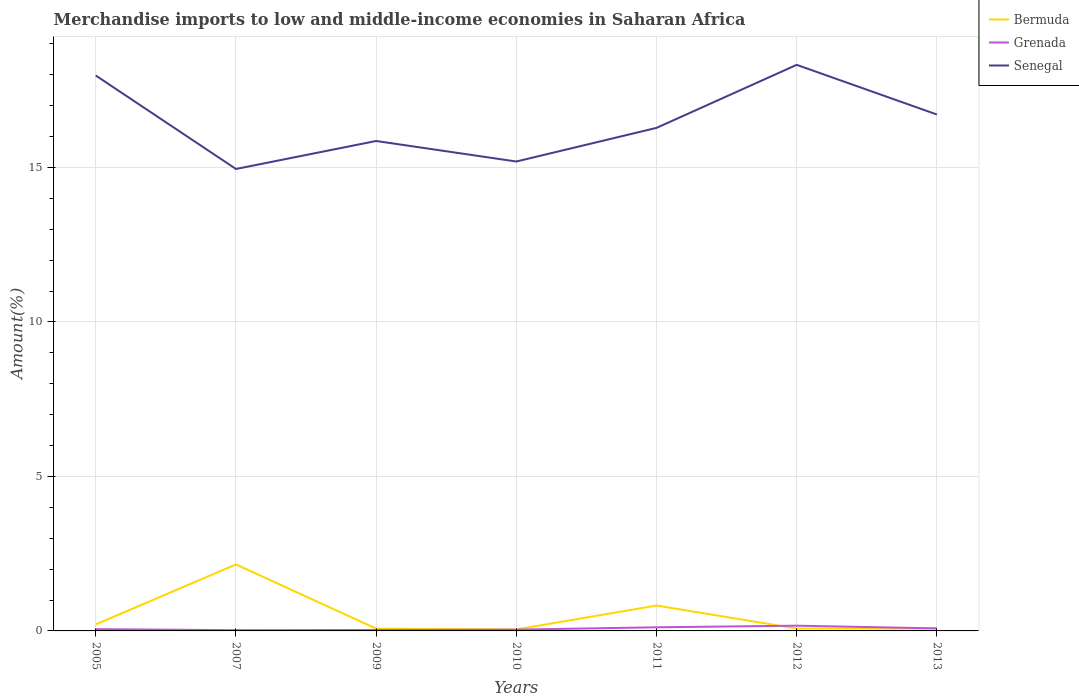Does the line corresponding to Senegal intersect with the line corresponding to Grenada?
Your answer should be very brief. No. Is the number of lines equal to the number of legend labels?
Keep it short and to the point. Yes. Across all years, what is the maximum percentage of amount earned from merchandise imports in Senegal?
Your answer should be very brief. 14.95. In which year was the percentage of amount earned from merchandise imports in Senegal maximum?
Give a very brief answer. 2007. What is the total percentage of amount earned from merchandise imports in Bermuda in the graph?
Your answer should be very brief. 0.75. What is the difference between the highest and the second highest percentage of amount earned from merchandise imports in Grenada?
Keep it short and to the point. 0.15. Is the percentage of amount earned from merchandise imports in Grenada strictly greater than the percentage of amount earned from merchandise imports in Bermuda over the years?
Give a very brief answer. No. What is the difference between two consecutive major ticks on the Y-axis?
Make the answer very short. 5. Are the values on the major ticks of Y-axis written in scientific E-notation?
Your response must be concise. No. Does the graph contain any zero values?
Provide a short and direct response. No. Does the graph contain grids?
Offer a terse response. Yes. How many legend labels are there?
Offer a very short reply. 3. How are the legend labels stacked?
Offer a very short reply. Vertical. What is the title of the graph?
Keep it short and to the point. Merchandise imports to low and middle-income economies in Saharan Africa. Does "Panama" appear as one of the legend labels in the graph?
Your answer should be compact. No. What is the label or title of the Y-axis?
Your answer should be compact. Amount(%). What is the Amount(%) of Bermuda in 2005?
Your answer should be compact. 0.21. What is the Amount(%) in Grenada in 2005?
Give a very brief answer. 0.06. What is the Amount(%) in Senegal in 2005?
Ensure brevity in your answer.  17.98. What is the Amount(%) of Bermuda in 2007?
Make the answer very short. 2.15. What is the Amount(%) of Grenada in 2007?
Provide a succinct answer. 0.02. What is the Amount(%) of Senegal in 2007?
Provide a succinct answer. 14.95. What is the Amount(%) of Bermuda in 2009?
Provide a succinct answer. 0.07. What is the Amount(%) in Grenada in 2009?
Offer a very short reply. 0.03. What is the Amount(%) of Senegal in 2009?
Provide a succinct answer. 15.86. What is the Amount(%) of Bermuda in 2010?
Your answer should be compact. 0.05. What is the Amount(%) of Grenada in 2010?
Make the answer very short. 0.04. What is the Amount(%) of Senegal in 2010?
Offer a very short reply. 15.19. What is the Amount(%) of Bermuda in 2011?
Keep it short and to the point. 0.82. What is the Amount(%) in Grenada in 2011?
Keep it short and to the point. 0.12. What is the Amount(%) of Senegal in 2011?
Keep it short and to the point. 16.28. What is the Amount(%) in Bermuda in 2012?
Provide a succinct answer. 0.08. What is the Amount(%) in Grenada in 2012?
Your answer should be compact. 0.17. What is the Amount(%) in Senegal in 2012?
Your answer should be very brief. 18.32. What is the Amount(%) of Bermuda in 2013?
Offer a terse response. 0.08. What is the Amount(%) in Grenada in 2013?
Make the answer very short. 0.08. What is the Amount(%) in Senegal in 2013?
Give a very brief answer. 16.72. Across all years, what is the maximum Amount(%) in Bermuda?
Your response must be concise. 2.15. Across all years, what is the maximum Amount(%) of Grenada?
Your answer should be compact. 0.17. Across all years, what is the maximum Amount(%) in Senegal?
Provide a succinct answer. 18.32. Across all years, what is the minimum Amount(%) in Bermuda?
Your response must be concise. 0.05. Across all years, what is the minimum Amount(%) of Grenada?
Your answer should be compact. 0.02. Across all years, what is the minimum Amount(%) in Senegal?
Offer a terse response. 14.95. What is the total Amount(%) of Bermuda in the graph?
Your answer should be very brief. 3.46. What is the total Amount(%) in Grenada in the graph?
Your answer should be compact. 0.52. What is the total Amount(%) in Senegal in the graph?
Make the answer very short. 115.31. What is the difference between the Amount(%) of Bermuda in 2005 and that in 2007?
Make the answer very short. -1.94. What is the difference between the Amount(%) in Grenada in 2005 and that in 2007?
Provide a succinct answer. 0.03. What is the difference between the Amount(%) of Senegal in 2005 and that in 2007?
Provide a short and direct response. 3.02. What is the difference between the Amount(%) of Bermuda in 2005 and that in 2009?
Offer a terse response. 0.14. What is the difference between the Amount(%) of Grenada in 2005 and that in 2009?
Provide a short and direct response. 0.03. What is the difference between the Amount(%) of Senegal in 2005 and that in 2009?
Offer a terse response. 2.12. What is the difference between the Amount(%) in Bermuda in 2005 and that in 2010?
Offer a terse response. 0.16. What is the difference between the Amount(%) of Grenada in 2005 and that in 2010?
Offer a terse response. 0.02. What is the difference between the Amount(%) of Senegal in 2005 and that in 2010?
Provide a succinct answer. 2.78. What is the difference between the Amount(%) in Bermuda in 2005 and that in 2011?
Your answer should be compact. -0.61. What is the difference between the Amount(%) of Grenada in 2005 and that in 2011?
Provide a short and direct response. -0.06. What is the difference between the Amount(%) of Senegal in 2005 and that in 2011?
Offer a very short reply. 1.69. What is the difference between the Amount(%) in Bermuda in 2005 and that in 2012?
Make the answer very short. 0.13. What is the difference between the Amount(%) in Grenada in 2005 and that in 2012?
Your answer should be very brief. -0.11. What is the difference between the Amount(%) in Senegal in 2005 and that in 2012?
Offer a terse response. -0.35. What is the difference between the Amount(%) of Bermuda in 2005 and that in 2013?
Make the answer very short. 0.13. What is the difference between the Amount(%) of Grenada in 2005 and that in 2013?
Provide a short and direct response. -0.02. What is the difference between the Amount(%) in Senegal in 2005 and that in 2013?
Ensure brevity in your answer.  1.26. What is the difference between the Amount(%) of Bermuda in 2007 and that in 2009?
Provide a succinct answer. 2.08. What is the difference between the Amount(%) in Grenada in 2007 and that in 2009?
Your answer should be very brief. -0.01. What is the difference between the Amount(%) in Senegal in 2007 and that in 2009?
Your answer should be compact. -0.91. What is the difference between the Amount(%) of Bermuda in 2007 and that in 2010?
Provide a succinct answer. 2.1. What is the difference between the Amount(%) of Grenada in 2007 and that in 2010?
Your answer should be very brief. -0.02. What is the difference between the Amount(%) in Senegal in 2007 and that in 2010?
Ensure brevity in your answer.  -0.24. What is the difference between the Amount(%) in Bermuda in 2007 and that in 2011?
Offer a terse response. 1.33. What is the difference between the Amount(%) of Grenada in 2007 and that in 2011?
Ensure brevity in your answer.  -0.09. What is the difference between the Amount(%) of Senegal in 2007 and that in 2011?
Offer a terse response. -1.33. What is the difference between the Amount(%) of Bermuda in 2007 and that in 2012?
Make the answer very short. 2.08. What is the difference between the Amount(%) of Grenada in 2007 and that in 2012?
Make the answer very short. -0.15. What is the difference between the Amount(%) in Senegal in 2007 and that in 2012?
Offer a very short reply. -3.37. What is the difference between the Amount(%) of Bermuda in 2007 and that in 2013?
Ensure brevity in your answer.  2.08. What is the difference between the Amount(%) of Grenada in 2007 and that in 2013?
Keep it short and to the point. -0.06. What is the difference between the Amount(%) of Senegal in 2007 and that in 2013?
Keep it short and to the point. -1.76. What is the difference between the Amount(%) in Bermuda in 2009 and that in 2010?
Keep it short and to the point. 0.03. What is the difference between the Amount(%) of Grenada in 2009 and that in 2010?
Make the answer very short. -0.01. What is the difference between the Amount(%) in Senegal in 2009 and that in 2010?
Offer a very short reply. 0.66. What is the difference between the Amount(%) of Bermuda in 2009 and that in 2011?
Your answer should be compact. -0.75. What is the difference between the Amount(%) in Grenada in 2009 and that in 2011?
Provide a short and direct response. -0.09. What is the difference between the Amount(%) of Senegal in 2009 and that in 2011?
Your answer should be compact. -0.42. What is the difference between the Amount(%) in Bermuda in 2009 and that in 2012?
Provide a succinct answer. -0. What is the difference between the Amount(%) of Grenada in 2009 and that in 2012?
Give a very brief answer. -0.14. What is the difference between the Amount(%) in Senegal in 2009 and that in 2012?
Provide a short and direct response. -2.46. What is the difference between the Amount(%) in Bermuda in 2009 and that in 2013?
Your response must be concise. -0. What is the difference between the Amount(%) in Grenada in 2009 and that in 2013?
Your answer should be very brief. -0.05. What is the difference between the Amount(%) of Senegal in 2009 and that in 2013?
Give a very brief answer. -0.86. What is the difference between the Amount(%) of Bermuda in 2010 and that in 2011?
Make the answer very short. -0.77. What is the difference between the Amount(%) in Grenada in 2010 and that in 2011?
Your response must be concise. -0.07. What is the difference between the Amount(%) of Senegal in 2010 and that in 2011?
Offer a terse response. -1.09. What is the difference between the Amount(%) in Bermuda in 2010 and that in 2012?
Provide a short and direct response. -0.03. What is the difference between the Amount(%) of Grenada in 2010 and that in 2012?
Your answer should be very brief. -0.13. What is the difference between the Amount(%) in Senegal in 2010 and that in 2012?
Keep it short and to the point. -3.13. What is the difference between the Amount(%) in Bermuda in 2010 and that in 2013?
Give a very brief answer. -0.03. What is the difference between the Amount(%) in Grenada in 2010 and that in 2013?
Keep it short and to the point. -0.04. What is the difference between the Amount(%) in Senegal in 2010 and that in 2013?
Ensure brevity in your answer.  -1.52. What is the difference between the Amount(%) in Bermuda in 2011 and that in 2012?
Keep it short and to the point. 0.74. What is the difference between the Amount(%) of Grenada in 2011 and that in 2012?
Provide a succinct answer. -0.05. What is the difference between the Amount(%) of Senegal in 2011 and that in 2012?
Your answer should be very brief. -2.04. What is the difference between the Amount(%) in Bermuda in 2011 and that in 2013?
Provide a succinct answer. 0.75. What is the difference between the Amount(%) of Grenada in 2011 and that in 2013?
Provide a succinct answer. 0.04. What is the difference between the Amount(%) of Senegal in 2011 and that in 2013?
Offer a very short reply. -0.43. What is the difference between the Amount(%) in Grenada in 2012 and that in 2013?
Make the answer very short. 0.09. What is the difference between the Amount(%) of Senegal in 2012 and that in 2013?
Ensure brevity in your answer.  1.61. What is the difference between the Amount(%) in Bermuda in 2005 and the Amount(%) in Grenada in 2007?
Your answer should be very brief. 0.19. What is the difference between the Amount(%) of Bermuda in 2005 and the Amount(%) of Senegal in 2007?
Make the answer very short. -14.74. What is the difference between the Amount(%) of Grenada in 2005 and the Amount(%) of Senegal in 2007?
Ensure brevity in your answer.  -14.89. What is the difference between the Amount(%) in Bermuda in 2005 and the Amount(%) in Grenada in 2009?
Offer a very short reply. 0.18. What is the difference between the Amount(%) of Bermuda in 2005 and the Amount(%) of Senegal in 2009?
Make the answer very short. -15.65. What is the difference between the Amount(%) in Grenada in 2005 and the Amount(%) in Senegal in 2009?
Provide a short and direct response. -15.8. What is the difference between the Amount(%) in Bermuda in 2005 and the Amount(%) in Grenada in 2010?
Your answer should be very brief. 0.17. What is the difference between the Amount(%) in Bermuda in 2005 and the Amount(%) in Senegal in 2010?
Provide a short and direct response. -14.98. What is the difference between the Amount(%) of Grenada in 2005 and the Amount(%) of Senegal in 2010?
Provide a succinct answer. -15.14. What is the difference between the Amount(%) in Bermuda in 2005 and the Amount(%) in Grenada in 2011?
Provide a succinct answer. 0.09. What is the difference between the Amount(%) of Bermuda in 2005 and the Amount(%) of Senegal in 2011?
Provide a succinct answer. -16.07. What is the difference between the Amount(%) of Grenada in 2005 and the Amount(%) of Senegal in 2011?
Ensure brevity in your answer.  -16.23. What is the difference between the Amount(%) of Bermuda in 2005 and the Amount(%) of Grenada in 2012?
Offer a very short reply. 0.04. What is the difference between the Amount(%) of Bermuda in 2005 and the Amount(%) of Senegal in 2012?
Give a very brief answer. -18.11. What is the difference between the Amount(%) of Grenada in 2005 and the Amount(%) of Senegal in 2012?
Keep it short and to the point. -18.27. What is the difference between the Amount(%) in Bermuda in 2005 and the Amount(%) in Grenada in 2013?
Give a very brief answer. 0.13. What is the difference between the Amount(%) of Bermuda in 2005 and the Amount(%) of Senegal in 2013?
Your answer should be very brief. -16.51. What is the difference between the Amount(%) of Grenada in 2005 and the Amount(%) of Senegal in 2013?
Provide a succinct answer. -16.66. What is the difference between the Amount(%) of Bermuda in 2007 and the Amount(%) of Grenada in 2009?
Offer a terse response. 2.12. What is the difference between the Amount(%) in Bermuda in 2007 and the Amount(%) in Senegal in 2009?
Provide a succinct answer. -13.71. What is the difference between the Amount(%) in Grenada in 2007 and the Amount(%) in Senegal in 2009?
Give a very brief answer. -15.83. What is the difference between the Amount(%) in Bermuda in 2007 and the Amount(%) in Grenada in 2010?
Make the answer very short. 2.11. What is the difference between the Amount(%) of Bermuda in 2007 and the Amount(%) of Senegal in 2010?
Your answer should be compact. -13.04. What is the difference between the Amount(%) in Grenada in 2007 and the Amount(%) in Senegal in 2010?
Your answer should be compact. -15.17. What is the difference between the Amount(%) of Bermuda in 2007 and the Amount(%) of Grenada in 2011?
Make the answer very short. 2.04. What is the difference between the Amount(%) of Bermuda in 2007 and the Amount(%) of Senegal in 2011?
Make the answer very short. -14.13. What is the difference between the Amount(%) of Grenada in 2007 and the Amount(%) of Senegal in 2011?
Your response must be concise. -16.26. What is the difference between the Amount(%) of Bermuda in 2007 and the Amount(%) of Grenada in 2012?
Offer a terse response. 1.98. What is the difference between the Amount(%) of Bermuda in 2007 and the Amount(%) of Senegal in 2012?
Your answer should be very brief. -16.17. What is the difference between the Amount(%) of Grenada in 2007 and the Amount(%) of Senegal in 2012?
Provide a succinct answer. -18.3. What is the difference between the Amount(%) in Bermuda in 2007 and the Amount(%) in Grenada in 2013?
Keep it short and to the point. 2.07. What is the difference between the Amount(%) in Bermuda in 2007 and the Amount(%) in Senegal in 2013?
Keep it short and to the point. -14.56. What is the difference between the Amount(%) of Grenada in 2007 and the Amount(%) of Senegal in 2013?
Provide a short and direct response. -16.69. What is the difference between the Amount(%) in Bermuda in 2009 and the Amount(%) in Grenada in 2010?
Ensure brevity in your answer.  0.03. What is the difference between the Amount(%) of Bermuda in 2009 and the Amount(%) of Senegal in 2010?
Make the answer very short. -15.12. What is the difference between the Amount(%) in Grenada in 2009 and the Amount(%) in Senegal in 2010?
Your answer should be very brief. -15.16. What is the difference between the Amount(%) in Bermuda in 2009 and the Amount(%) in Grenada in 2011?
Provide a short and direct response. -0.04. What is the difference between the Amount(%) of Bermuda in 2009 and the Amount(%) of Senegal in 2011?
Give a very brief answer. -16.21. What is the difference between the Amount(%) in Grenada in 2009 and the Amount(%) in Senegal in 2011?
Your answer should be very brief. -16.25. What is the difference between the Amount(%) in Bermuda in 2009 and the Amount(%) in Grenada in 2012?
Your response must be concise. -0.1. What is the difference between the Amount(%) of Bermuda in 2009 and the Amount(%) of Senegal in 2012?
Make the answer very short. -18.25. What is the difference between the Amount(%) in Grenada in 2009 and the Amount(%) in Senegal in 2012?
Give a very brief answer. -18.29. What is the difference between the Amount(%) of Bermuda in 2009 and the Amount(%) of Grenada in 2013?
Make the answer very short. -0.01. What is the difference between the Amount(%) in Bermuda in 2009 and the Amount(%) in Senegal in 2013?
Your answer should be very brief. -16.64. What is the difference between the Amount(%) of Grenada in 2009 and the Amount(%) of Senegal in 2013?
Offer a terse response. -16.69. What is the difference between the Amount(%) in Bermuda in 2010 and the Amount(%) in Grenada in 2011?
Make the answer very short. -0.07. What is the difference between the Amount(%) of Bermuda in 2010 and the Amount(%) of Senegal in 2011?
Provide a short and direct response. -16.24. What is the difference between the Amount(%) in Grenada in 2010 and the Amount(%) in Senegal in 2011?
Offer a very short reply. -16.24. What is the difference between the Amount(%) of Bermuda in 2010 and the Amount(%) of Grenada in 2012?
Ensure brevity in your answer.  -0.12. What is the difference between the Amount(%) in Bermuda in 2010 and the Amount(%) in Senegal in 2012?
Your answer should be compact. -18.28. What is the difference between the Amount(%) of Grenada in 2010 and the Amount(%) of Senegal in 2012?
Give a very brief answer. -18.28. What is the difference between the Amount(%) of Bermuda in 2010 and the Amount(%) of Grenada in 2013?
Offer a terse response. -0.03. What is the difference between the Amount(%) of Bermuda in 2010 and the Amount(%) of Senegal in 2013?
Offer a terse response. -16.67. What is the difference between the Amount(%) of Grenada in 2010 and the Amount(%) of Senegal in 2013?
Offer a terse response. -16.67. What is the difference between the Amount(%) of Bermuda in 2011 and the Amount(%) of Grenada in 2012?
Give a very brief answer. 0.65. What is the difference between the Amount(%) in Bermuda in 2011 and the Amount(%) in Senegal in 2012?
Your response must be concise. -17.5. What is the difference between the Amount(%) in Grenada in 2011 and the Amount(%) in Senegal in 2012?
Ensure brevity in your answer.  -18.21. What is the difference between the Amount(%) in Bermuda in 2011 and the Amount(%) in Grenada in 2013?
Make the answer very short. 0.74. What is the difference between the Amount(%) of Bermuda in 2011 and the Amount(%) of Senegal in 2013?
Your response must be concise. -15.89. What is the difference between the Amount(%) in Grenada in 2011 and the Amount(%) in Senegal in 2013?
Keep it short and to the point. -16.6. What is the difference between the Amount(%) of Bermuda in 2012 and the Amount(%) of Grenada in 2013?
Your answer should be very brief. -0.01. What is the difference between the Amount(%) in Bermuda in 2012 and the Amount(%) in Senegal in 2013?
Provide a succinct answer. -16.64. What is the difference between the Amount(%) in Grenada in 2012 and the Amount(%) in Senegal in 2013?
Make the answer very short. -16.55. What is the average Amount(%) of Bermuda per year?
Keep it short and to the point. 0.49. What is the average Amount(%) of Grenada per year?
Provide a short and direct response. 0.07. What is the average Amount(%) in Senegal per year?
Your answer should be compact. 16.47. In the year 2005, what is the difference between the Amount(%) of Bermuda and Amount(%) of Grenada?
Give a very brief answer. 0.15. In the year 2005, what is the difference between the Amount(%) of Bermuda and Amount(%) of Senegal?
Provide a short and direct response. -17.77. In the year 2005, what is the difference between the Amount(%) in Grenada and Amount(%) in Senegal?
Your answer should be compact. -17.92. In the year 2007, what is the difference between the Amount(%) in Bermuda and Amount(%) in Grenada?
Your answer should be very brief. 2.13. In the year 2007, what is the difference between the Amount(%) in Bermuda and Amount(%) in Senegal?
Give a very brief answer. -12.8. In the year 2007, what is the difference between the Amount(%) of Grenada and Amount(%) of Senegal?
Offer a terse response. -14.93. In the year 2009, what is the difference between the Amount(%) of Bermuda and Amount(%) of Grenada?
Keep it short and to the point. 0.04. In the year 2009, what is the difference between the Amount(%) in Bermuda and Amount(%) in Senegal?
Give a very brief answer. -15.79. In the year 2009, what is the difference between the Amount(%) of Grenada and Amount(%) of Senegal?
Your response must be concise. -15.83. In the year 2010, what is the difference between the Amount(%) of Bermuda and Amount(%) of Grenada?
Your answer should be compact. 0.01. In the year 2010, what is the difference between the Amount(%) of Bermuda and Amount(%) of Senegal?
Offer a terse response. -15.15. In the year 2010, what is the difference between the Amount(%) in Grenada and Amount(%) in Senegal?
Provide a succinct answer. -15.15. In the year 2011, what is the difference between the Amount(%) in Bermuda and Amount(%) in Grenada?
Keep it short and to the point. 0.7. In the year 2011, what is the difference between the Amount(%) in Bermuda and Amount(%) in Senegal?
Offer a terse response. -15.46. In the year 2011, what is the difference between the Amount(%) in Grenada and Amount(%) in Senegal?
Ensure brevity in your answer.  -16.17. In the year 2012, what is the difference between the Amount(%) in Bermuda and Amount(%) in Grenada?
Keep it short and to the point. -0.09. In the year 2012, what is the difference between the Amount(%) in Bermuda and Amount(%) in Senegal?
Make the answer very short. -18.25. In the year 2012, what is the difference between the Amount(%) of Grenada and Amount(%) of Senegal?
Your answer should be compact. -18.15. In the year 2013, what is the difference between the Amount(%) in Bermuda and Amount(%) in Grenada?
Your response must be concise. -0.01. In the year 2013, what is the difference between the Amount(%) in Bermuda and Amount(%) in Senegal?
Make the answer very short. -16.64. In the year 2013, what is the difference between the Amount(%) in Grenada and Amount(%) in Senegal?
Your answer should be compact. -16.63. What is the ratio of the Amount(%) of Bermuda in 2005 to that in 2007?
Make the answer very short. 0.1. What is the ratio of the Amount(%) in Grenada in 2005 to that in 2007?
Your answer should be compact. 2.38. What is the ratio of the Amount(%) of Senegal in 2005 to that in 2007?
Offer a very short reply. 1.2. What is the ratio of the Amount(%) of Bermuda in 2005 to that in 2009?
Give a very brief answer. 2.85. What is the ratio of the Amount(%) of Grenada in 2005 to that in 2009?
Your answer should be compact. 1.95. What is the ratio of the Amount(%) of Senegal in 2005 to that in 2009?
Your answer should be very brief. 1.13. What is the ratio of the Amount(%) in Bermuda in 2005 to that in 2010?
Your answer should be very brief. 4.38. What is the ratio of the Amount(%) in Grenada in 2005 to that in 2010?
Your answer should be compact. 1.38. What is the ratio of the Amount(%) in Senegal in 2005 to that in 2010?
Keep it short and to the point. 1.18. What is the ratio of the Amount(%) in Bermuda in 2005 to that in 2011?
Provide a short and direct response. 0.26. What is the ratio of the Amount(%) in Grenada in 2005 to that in 2011?
Offer a very short reply. 0.5. What is the ratio of the Amount(%) of Senegal in 2005 to that in 2011?
Provide a succinct answer. 1.1. What is the ratio of the Amount(%) of Bermuda in 2005 to that in 2012?
Provide a succinct answer. 2.74. What is the ratio of the Amount(%) in Grenada in 2005 to that in 2012?
Provide a succinct answer. 0.34. What is the ratio of the Amount(%) of Senegal in 2005 to that in 2012?
Provide a short and direct response. 0.98. What is the ratio of the Amount(%) of Bermuda in 2005 to that in 2013?
Your response must be concise. 2.74. What is the ratio of the Amount(%) of Grenada in 2005 to that in 2013?
Your response must be concise. 0.71. What is the ratio of the Amount(%) of Senegal in 2005 to that in 2013?
Give a very brief answer. 1.08. What is the ratio of the Amount(%) of Bermuda in 2007 to that in 2009?
Your answer should be very brief. 29.16. What is the ratio of the Amount(%) of Grenada in 2007 to that in 2009?
Your response must be concise. 0.82. What is the ratio of the Amount(%) of Senegal in 2007 to that in 2009?
Your answer should be very brief. 0.94. What is the ratio of the Amount(%) of Bermuda in 2007 to that in 2010?
Your response must be concise. 44.79. What is the ratio of the Amount(%) of Grenada in 2007 to that in 2010?
Make the answer very short. 0.58. What is the ratio of the Amount(%) of Senegal in 2007 to that in 2010?
Your answer should be compact. 0.98. What is the ratio of the Amount(%) in Bermuda in 2007 to that in 2011?
Your answer should be compact. 2.62. What is the ratio of the Amount(%) of Grenada in 2007 to that in 2011?
Provide a short and direct response. 0.21. What is the ratio of the Amount(%) of Senegal in 2007 to that in 2011?
Your answer should be compact. 0.92. What is the ratio of the Amount(%) in Bermuda in 2007 to that in 2012?
Provide a succinct answer. 28. What is the ratio of the Amount(%) of Grenada in 2007 to that in 2012?
Keep it short and to the point. 0.14. What is the ratio of the Amount(%) of Senegal in 2007 to that in 2012?
Give a very brief answer. 0.82. What is the ratio of the Amount(%) in Bermuda in 2007 to that in 2013?
Give a very brief answer. 28.06. What is the ratio of the Amount(%) of Grenada in 2007 to that in 2013?
Give a very brief answer. 0.3. What is the ratio of the Amount(%) of Senegal in 2007 to that in 2013?
Ensure brevity in your answer.  0.89. What is the ratio of the Amount(%) in Bermuda in 2009 to that in 2010?
Your answer should be very brief. 1.54. What is the ratio of the Amount(%) of Grenada in 2009 to that in 2010?
Provide a succinct answer. 0.71. What is the ratio of the Amount(%) in Senegal in 2009 to that in 2010?
Provide a short and direct response. 1.04. What is the ratio of the Amount(%) of Bermuda in 2009 to that in 2011?
Your answer should be very brief. 0.09. What is the ratio of the Amount(%) in Grenada in 2009 to that in 2011?
Your answer should be very brief. 0.25. What is the ratio of the Amount(%) in Senegal in 2009 to that in 2011?
Your response must be concise. 0.97. What is the ratio of the Amount(%) in Bermuda in 2009 to that in 2012?
Your answer should be compact. 0.96. What is the ratio of the Amount(%) in Grenada in 2009 to that in 2012?
Give a very brief answer. 0.18. What is the ratio of the Amount(%) in Senegal in 2009 to that in 2012?
Provide a short and direct response. 0.87. What is the ratio of the Amount(%) of Bermuda in 2009 to that in 2013?
Provide a succinct answer. 0.96. What is the ratio of the Amount(%) in Grenada in 2009 to that in 2013?
Ensure brevity in your answer.  0.36. What is the ratio of the Amount(%) of Senegal in 2009 to that in 2013?
Your answer should be compact. 0.95. What is the ratio of the Amount(%) of Bermuda in 2010 to that in 2011?
Keep it short and to the point. 0.06. What is the ratio of the Amount(%) of Grenada in 2010 to that in 2011?
Ensure brevity in your answer.  0.36. What is the ratio of the Amount(%) of Senegal in 2010 to that in 2011?
Keep it short and to the point. 0.93. What is the ratio of the Amount(%) of Bermuda in 2010 to that in 2012?
Make the answer very short. 0.63. What is the ratio of the Amount(%) of Grenada in 2010 to that in 2012?
Offer a very short reply. 0.25. What is the ratio of the Amount(%) in Senegal in 2010 to that in 2012?
Offer a very short reply. 0.83. What is the ratio of the Amount(%) in Bermuda in 2010 to that in 2013?
Provide a succinct answer. 0.63. What is the ratio of the Amount(%) in Grenada in 2010 to that in 2013?
Offer a terse response. 0.51. What is the ratio of the Amount(%) in Senegal in 2010 to that in 2013?
Your answer should be compact. 0.91. What is the ratio of the Amount(%) in Bermuda in 2011 to that in 2012?
Offer a terse response. 10.69. What is the ratio of the Amount(%) of Grenada in 2011 to that in 2012?
Your answer should be very brief. 0.69. What is the ratio of the Amount(%) of Senegal in 2011 to that in 2012?
Your answer should be very brief. 0.89. What is the ratio of the Amount(%) in Bermuda in 2011 to that in 2013?
Keep it short and to the point. 10.71. What is the ratio of the Amount(%) of Grenada in 2011 to that in 2013?
Your answer should be very brief. 1.43. What is the ratio of the Amount(%) of Senegal in 2011 to that in 2013?
Ensure brevity in your answer.  0.97. What is the ratio of the Amount(%) of Bermuda in 2012 to that in 2013?
Provide a short and direct response. 1. What is the ratio of the Amount(%) in Grenada in 2012 to that in 2013?
Your response must be concise. 2.06. What is the ratio of the Amount(%) of Senegal in 2012 to that in 2013?
Your answer should be very brief. 1.1. What is the difference between the highest and the second highest Amount(%) in Bermuda?
Provide a short and direct response. 1.33. What is the difference between the highest and the second highest Amount(%) in Grenada?
Your answer should be compact. 0.05. What is the difference between the highest and the second highest Amount(%) of Senegal?
Make the answer very short. 0.35. What is the difference between the highest and the lowest Amount(%) of Bermuda?
Provide a succinct answer. 2.1. What is the difference between the highest and the lowest Amount(%) of Grenada?
Your answer should be compact. 0.15. What is the difference between the highest and the lowest Amount(%) in Senegal?
Your answer should be compact. 3.37. 